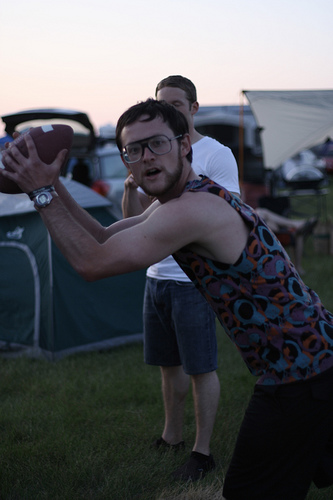<image>
Can you confirm if the awning is behind the tent? Yes. From this viewpoint, the awning is positioned behind the tent, with the tent partially or fully occluding the awning. Where is the man in relation to the ball? Is it on the ball? No. The man is not positioned on the ball. They may be near each other, but the man is not supported by or resting on top of the ball. 